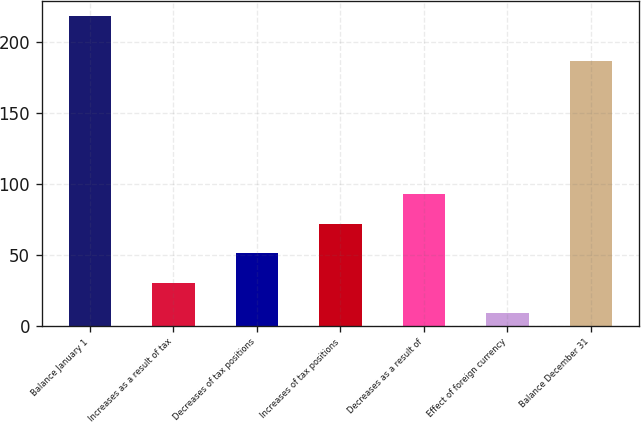Convert chart to OTSL. <chart><loc_0><loc_0><loc_500><loc_500><bar_chart><fcel>Balance January 1<fcel>Increases as a result of tax<fcel>Decreases of tax positions<fcel>Increases of tax positions<fcel>Decreases as a result of<fcel>Effect of foreign currency<fcel>Balance December 31<nl><fcel>218<fcel>29.9<fcel>50.8<fcel>71.7<fcel>92.6<fcel>9<fcel>186<nl></chart> 